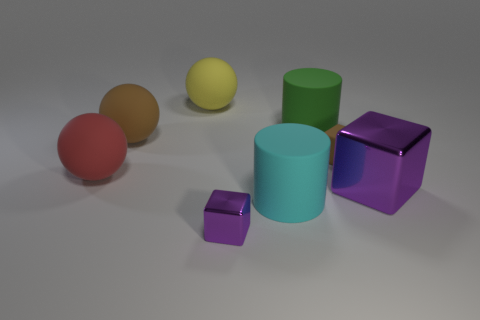Is there a matte block of the same size as the brown ball?
Provide a succinct answer. No. There is a big object that is both behind the large brown rubber sphere and left of the cyan cylinder; what is it made of?
Keep it short and to the point. Rubber. How many metal things are green things or purple spheres?
Make the answer very short. 0. The other tiny thing that is made of the same material as the cyan thing is what shape?
Ensure brevity in your answer.  Cube. What number of large matte things are to the left of the large yellow sphere and in front of the red matte object?
Your response must be concise. 0. Is there anything else that is the same shape as the yellow thing?
Your answer should be very brief. Yes. There is a metallic block behind the small purple shiny block; what size is it?
Give a very brief answer. Large. What number of other things are the same color as the small metallic block?
Make the answer very short. 1. The tiny block behind the small object in front of the large red rubber sphere is made of what material?
Keep it short and to the point. Rubber. There is a big cube that is in front of the red rubber sphere; is its color the same as the tiny metallic object?
Provide a succinct answer. Yes. 